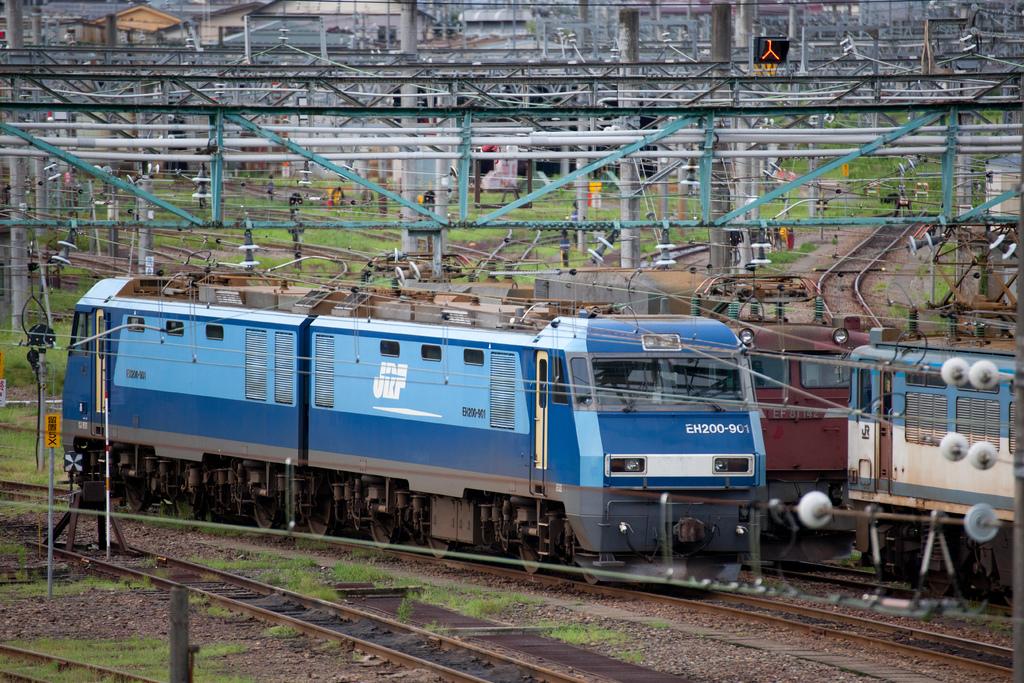What number is on the front of the train?
Keep it short and to the point. Eh200-901. What number is on the side of the train?
Offer a terse response. Eh200-901. 